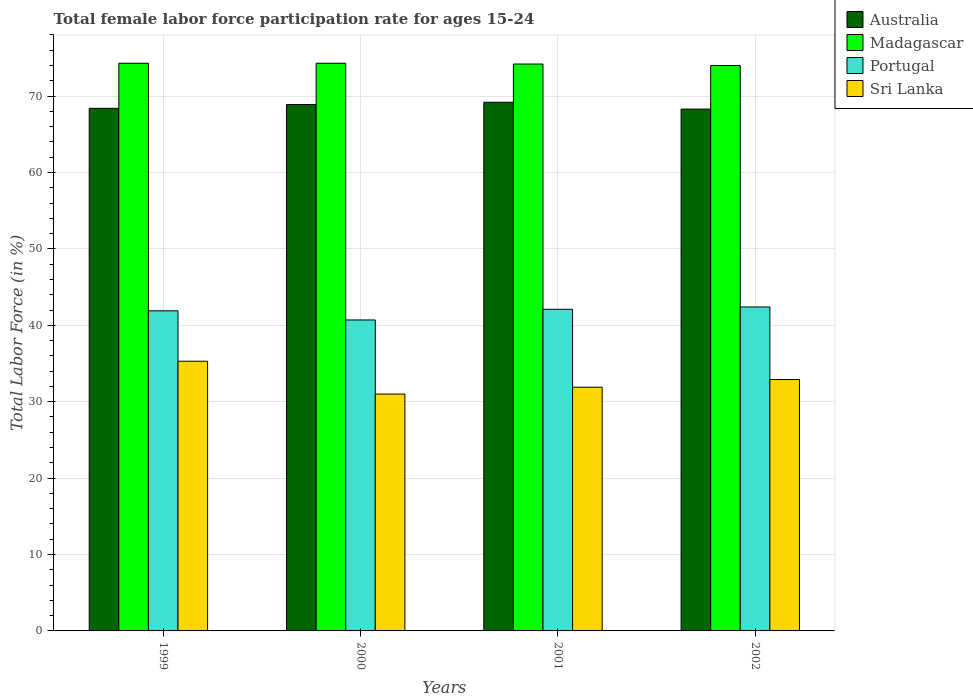Are the number of bars per tick equal to the number of legend labels?
Your response must be concise. Yes. Are the number of bars on each tick of the X-axis equal?
Your answer should be very brief. Yes. How many bars are there on the 4th tick from the right?
Your answer should be compact. 4. What is the label of the 4th group of bars from the left?
Offer a terse response. 2002. In how many cases, is the number of bars for a given year not equal to the number of legend labels?
Offer a very short reply. 0. What is the female labor force participation rate in Sri Lanka in 2001?
Offer a very short reply. 31.9. Across all years, what is the maximum female labor force participation rate in Portugal?
Your response must be concise. 42.4. Across all years, what is the minimum female labor force participation rate in Portugal?
Offer a very short reply. 40.7. In which year was the female labor force participation rate in Madagascar maximum?
Your response must be concise. 1999. What is the total female labor force participation rate in Madagascar in the graph?
Offer a terse response. 296.8. What is the difference between the female labor force participation rate in Australia in 2000 and that in 2001?
Provide a succinct answer. -0.3. What is the difference between the female labor force participation rate in Madagascar in 2000 and the female labor force participation rate in Australia in 2001?
Keep it short and to the point. 5.1. What is the average female labor force participation rate in Portugal per year?
Your response must be concise. 41.78. In the year 2001, what is the difference between the female labor force participation rate in Australia and female labor force participation rate in Sri Lanka?
Provide a short and direct response. 37.3. What is the ratio of the female labor force participation rate in Madagascar in 1999 to that in 2001?
Ensure brevity in your answer.  1. Is the female labor force participation rate in Madagascar in 1999 less than that in 2000?
Ensure brevity in your answer.  No. What is the difference between the highest and the second highest female labor force participation rate in Australia?
Provide a short and direct response. 0.3. What is the difference between the highest and the lowest female labor force participation rate in Australia?
Keep it short and to the point. 0.9. In how many years, is the female labor force participation rate in Portugal greater than the average female labor force participation rate in Portugal taken over all years?
Your response must be concise. 3. What does the 3rd bar from the right in 2001 represents?
Your answer should be compact. Madagascar. Are the values on the major ticks of Y-axis written in scientific E-notation?
Keep it short and to the point. No. Where does the legend appear in the graph?
Make the answer very short. Top right. What is the title of the graph?
Offer a very short reply. Total female labor force participation rate for ages 15-24. Does "Slovenia" appear as one of the legend labels in the graph?
Give a very brief answer. No. What is the Total Labor Force (in %) of Australia in 1999?
Provide a succinct answer. 68.4. What is the Total Labor Force (in %) in Madagascar in 1999?
Make the answer very short. 74.3. What is the Total Labor Force (in %) of Portugal in 1999?
Your answer should be very brief. 41.9. What is the Total Labor Force (in %) in Sri Lanka in 1999?
Give a very brief answer. 35.3. What is the Total Labor Force (in %) of Australia in 2000?
Ensure brevity in your answer.  68.9. What is the Total Labor Force (in %) in Madagascar in 2000?
Provide a succinct answer. 74.3. What is the Total Labor Force (in %) of Portugal in 2000?
Give a very brief answer. 40.7. What is the Total Labor Force (in %) of Sri Lanka in 2000?
Make the answer very short. 31. What is the Total Labor Force (in %) of Australia in 2001?
Make the answer very short. 69.2. What is the Total Labor Force (in %) of Madagascar in 2001?
Provide a succinct answer. 74.2. What is the Total Labor Force (in %) of Portugal in 2001?
Your answer should be very brief. 42.1. What is the Total Labor Force (in %) in Sri Lanka in 2001?
Ensure brevity in your answer.  31.9. What is the Total Labor Force (in %) of Australia in 2002?
Provide a short and direct response. 68.3. What is the Total Labor Force (in %) in Madagascar in 2002?
Your answer should be compact. 74. What is the Total Labor Force (in %) of Portugal in 2002?
Your response must be concise. 42.4. What is the Total Labor Force (in %) in Sri Lanka in 2002?
Offer a very short reply. 32.9. Across all years, what is the maximum Total Labor Force (in %) in Australia?
Offer a terse response. 69.2. Across all years, what is the maximum Total Labor Force (in %) of Madagascar?
Make the answer very short. 74.3. Across all years, what is the maximum Total Labor Force (in %) in Portugal?
Your answer should be compact. 42.4. Across all years, what is the maximum Total Labor Force (in %) in Sri Lanka?
Your response must be concise. 35.3. Across all years, what is the minimum Total Labor Force (in %) of Australia?
Offer a very short reply. 68.3. Across all years, what is the minimum Total Labor Force (in %) of Portugal?
Your answer should be compact. 40.7. Across all years, what is the minimum Total Labor Force (in %) of Sri Lanka?
Keep it short and to the point. 31. What is the total Total Labor Force (in %) in Australia in the graph?
Make the answer very short. 274.8. What is the total Total Labor Force (in %) in Madagascar in the graph?
Provide a succinct answer. 296.8. What is the total Total Labor Force (in %) in Portugal in the graph?
Make the answer very short. 167.1. What is the total Total Labor Force (in %) of Sri Lanka in the graph?
Make the answer very short. 131.1. What is the difference between the Total Labor Force (in %) of Australia in 1999 and that in 2001?
Provide a short and direct response. -0.8. What is the difference between the Total Labor Force (in %) of Portugal in 1999 and that in 2001?
Ensure brevity in your answer.  -0.2. What is the difference between the Total Labor Force (in %) in Australia in 1999 and that in 2002?
Make the answer very short. 0.1. What is the difference between the Total Labor Force (in %) of Madagascar in 1999 and that in 2002?
Offer a very short reply. 0.3. What is the difference between the Total Labor Force (in %) of Sri Lanka in 1999 and that in 2002?
Make the answer very short. 2.4. What is the difference between the Total Labor Force (in %) in Australia in 2000 and that in 2001?
Make the answer very short. -0.3. What is the difference between the Total Labor Force (in %) in Portugal in 2000 and that in 2001?
Offer a very short reply. -1.4. What is the difference between the Total Labor Force (in %) in Australia in 1999 and the Total Labor Force (in %) in Portugal in 2000?
Ensure brevity in your answer.  27.7. What is the difference between the Total Labor Force (in %) of Australia in 1999 and the Total Labor Force (in %) of Sri Lanka in 2000?
Your answer should be compact. 37.4. What is the difference between the Total Labor Force (in %) of Madagascar in 1999 and the Total Labor Force (in %) of Portugal in 2000?
Your answer should be very brief. 33.6. What is the difference between the Total Labor Force (in %) in Madagascar in 1999 and the Total Labor Force (in %) in Sri Lanka in 2000?
Provide a succinct answer. 43.3. What is the difference between the Total Labor Force (in %) in Portugal in 1999 and the Total Labor Force (in %) in Sri Lanka in 2000?
Provide a succinct answer. 10.9. What is the difference between the Total Labor Force (in %) in Australia in 1999 and the Total Labor Force (in %) in Portugal in 2001?
Offer a very short reply. 26.3. What is the difference between the Total Labor Force (in %) in Australia in 1999 and the Total Labor Force (in %) in Sri Lanka in 2001?
Make the answer very short. 36.5. What is the difference between the Total Labor Force (in %) in Madagascar in 1999 and the Total Labor Force (in %) in Portugal in 2001?
Offer a terse response. 32.2. What is the difference between the Total Labor Force (in %) in Madagascar in 1999 and the Total Labor Force (in %) in Sri Lanka in 2001?
Provide a short and direct response. 42.4. What is the difference between the Total Labor Force (in %) in Portugal in 1999 and the Total Labor Force (in %) in Sri Lanka in 2001?
Offer a very short reply. 10. What is the difference between the Total Labor Force (in %) of Australia in 1999 and the Total Labor Force (in %) of Portugal in 2002?
Keep it short and to the point. 26. What is the difference between the Total Labor Force (in %) of Australia in 1999 and the Total Labor Force (in %) of Sri Lanka in 2002?
Your answer should be compact. 35.5. What is the difference between the Total Labor Force (in %) of Madagascar in 1999 and the Total Labor Force (in %) of Portugal in 2002?
Make the answer very short. 31.9. What is the difference between the Total Labor Force (in %) of Madagascar in 1999 and the Total Labor Force (in %) of Sri Lanka in 2002?
Make the answer very short. 41.4. What is the difference between the Total Labor Force (in %) of Portugal in 1999 and the Total Labor Force (in %) of Sri Lanka in 2002?
Make the answer very short. 9. What is the difference between the Total Labor Force (in %) of Australia in 2000 and the Total Labor Force (in %) of Madagascar in 2001?
Give a very brief answer. -5.3. What is the difference between the Total Labor Force (in %) in Australia in 2000 and the Total Labor Force (in %) in Portugal in 2001?
Make the answer very short. 26.8. What is the difference between the Total Labor Force (in %) of Australia in 2000 and the Total Labor Force (in %) of Sri Lanka in 2001?
Offer a terse response. 37. What is the difference between the Total Labor Force (in %) of Madagascar in 2000 and the Total Labor Force (in %) of Portugal in 2001?
Make the answer very short. 32.2. What is the difference between the Total Labor Force (in %) in Madagascar in 2000 and the Total Labor Force (in %) in Sri Lanka in 2001?
Your answer should be compact. 42.4. What is the difference between the Total Labor Force (in %) of Madagascar in 2000 and the Total Labor Force (in %) of Portugal in 2002?
Your answer should be very brief. 31.9. What is the difference between the Total Labor Force (in %) of Madagascar in 2000 and the Total Labor Force (in %) of Sri Lanka in 2002?
Keep it short and to the point. 41.4. What is the difference between the Total Labor Force (in %) of Portugal in 2000 and the Total Labor Force (in %) of Sri Lanka in 2002?
Your answer should be very brief. 7.8. What is the difference between the Total Labor Force (in %) in Australia in 2001 and the Total Labor Force (in %) in Madagascar in 2002?
Your response must be concise. -4.8. What is the difference between the Total Labor Force (in %) in Australia in 2001 and the Total Labor Force (in %) in Portugal in 2002?
Ensure brevity in your answer.  26.8. What is the difference between the Total Labor Force (in %) in Australia in 2001 and the Total Labor Force (in %) in Sri Lanka in 2002?
Keep it short and to the point. 36.3. What is the difference between the Total Labor Force (in %) of Madagascar in 2001 and the Total Labor Force (in %) of Portugal in 2002?
Provide a succinct answer. 31.8. What is the difference between the Total Labor Force (in %) of Madagascar in 2001 and the Total Labor Force (in %) of Sri Lanka in 2002?
Offer a very short reply. 41.3. What is the average Total Labor Force (in %) in Australia per year?
Your response must be concise. 68.7. What is the average Total Labor Force (in %) in Madagascar per year?
Ensure brevity in your answer.  74.2. What is the average Total Labor Force (in %) in Portugal per year?
Ensure brevity in your answer.  41.77. What is the average Total Labor Force (in %) of Sri Lanka per year?
Provide a succinct answer. 32.77. In the year 1999, what is the difference between the Total Labor Force (in %) in Australia and Total Labor Force (in %) in Madagascar?
Your answer should be compact. -5.9. In the year 1999, what is the difference between the Total Labor Force (in %) of Australia and Total Labor Force (in %) of Portugal?
Keep it short and to the point. 26.5. In the year 1999, what is the difference between the Total Labor Force (in %) in Australia and Total Labor Force (in %) in Sri Lanka?
Provide a short and direct response. 33.1. In the year 1999, what is the difference between the Total Labor Force (in %) in Madagascar and Total Labor Force (in %) in Portugal?
Make the answer very short. 32.4. In the year 1999, what is the difference between the Total Labor Force (in %) in Madagascar and Total Labor Force (in %) in Sri Lanka?
Give a very brief answer. 39. In the year 1999, what is the difference between the Total Labor Force (in %) in Portugal and Total Labor Force (in %) in Sri Lanka?
Your answer should be compact. 6.6. In the year 2000, what is the difference between the Total Labor Force (in %) of Australia and Total Labor Force (in %) of Portugal?
Your answer should be very brief. 28.2. In the year 2000, what is the difference between the Total Labor Force (in %) in Australia and Total Labor Force (in %) in Sri Lanka?
Your answer should be very brief. 37.9. In the year 2000, what is the difference between the Total Labor Force (in %) of Madagascar and Total Labor Force (in %) of Portugal?
Provide a succinct answer. 33.6. In the year 2000, what is the difference between the Total Labor Force (in %) of Madagascar and Total Labor Force (in %) of Sri Lanka?
Your answer should be very brief. 43.3. In the year 2000, what is the difference between the Total Labor Force (in %) in Portugal and Total Labor Force (in %) in Sri Lanka?
Your answer should be very brief. 9.7. In the year 2001, what is the difference between the Total Labor Force (in %) of Australia and Total Labor Force (in %) of Madagascar?
Keep it short and to the point. -5. In the year 2001, what is the difference between the Total Labor Force (in %) of Australia and Total Labor Force (in %) of Portugal?
Your answer should be compact. 27.1. In the year 2001, what is the difference between the Total Labor Force (in %) in Australia and Total Labor Force (in %) in Sri Lanka?
Ensure brevity in your answer.  37.3. In the year 2001, what is the difference between the Total Labor Force (in %) of Madagascar and Total Labor Force (in %) of Portugal?
Give a very brief answer. 32.1. In the year 2001, what is the difference between the Total Labor Force (in %) of Madagascar and Total Labor Force (in %) of Sri Lanka?
Your response must be concise. 42.3. In the year 2001, what is the difference between the Total Labor Force (in %) of Portugal and Total Labor Force (in %) of Sri Lanka?
Give a very brief answer. 10.2. In the year 2002, what is the difference between the Total Labor Force (in %) in Australia and Total Labor Force (in %) in Portugal?
Offer a terse response. 25.9. In the year 2002, what is the difference between the Total Labor Force (in %) of Australia and Total Labor Force (in %) of Sri Lanka?
Your response must be concise. 35.4. In the year 2002, what is the difference between the Total Labor Force (in %) in Madagascar and Total Labor Force (in %) in Portugal?
Give a very brief answer. 31.6. In the year 2002, what is the difference between the Total Labor Force (in %) in Madagascar and Total Labor Force (in %) in Sri Lanka?
Ensure brevity in your answer.  41.1. In the year 2002, what is the difference between the Total Labor Force (in %) of Portugal and Total Labor Force (in %) of Sri Lanka?
Keep it short and to the point. 9.5. What is the ratio of the Total Labor Force (in %) in Australia in 1999 to that in 2000?
Offer a terse response. 0.99. What is the ratio of the Total Labor Force (in %) of Madagascar in 1999 to that in 2000?
Ensure brevity in your answer.  1. What is the ratio of the Total Labor Force (in %) in Portugal in 1999 to that in 2000?
Ensure brevity in your answer.  1.03. What is the ratio of the Total Labor Force (in %) in Sri Lanka in 1999 to that in 2000?
Give a very brief answer. 1.14. What is the ratio of the Total Labor Force (in %) in Australia in 1999 to that in 2001?
Make the answer very short. 0.99. What is the ratio of the Total Labor Force (in %) of Madagascar in 1999 to that in 2001?
Provide a short and direct response. 1. What is the ratio of the Total Labor Force (in %) of Sri Lanka in 1999 to that in 2001?
Provide a short and direct response. 1.11. What is the ratio of the Total Labor Force (in %) in Sri Lanka in 1999 to that in 2002?
Ensure brevity in your answer.  1.07. What is the ratio of the Total Labor Force (in %) of Madagascar in 2000 to that in 2001?
Your response must be concise. 1. What is the ratio of the Total Labor Force (in %) in Portugal in 2000 to that in 2001?
Provide a short and direct response. 0.97. What is the ratio of the Total Labor Force (in %) in Sri Lanka in 2000 to that in 2001?
Your answer should be compact. 0.97. What is the ratio of the Total Labor Force (in %) in Australia in 2000 to that in 2002?
Give a very brief answer. 1.01. What is the ratio of the Total Labor Force (in %) of Portugal in 2000 to that in 2002?
Offer a very short reply. 0.96. What is the ratio of the Total Labor Force (in %) in Sri Lanka in 2000 to that in 2002?
Offer a terse response. 0.94. What is the ratio of the Total Labor Force (in %) in Australia in 2001 to that in 2002?
Ensure brevity in your answer.  1.01. What is the ratio of the Total Labor Force (in %) in Madagascar in 2001 to that in 2002?
Make the answer very short. 1. What is the ratio of the Total Labor Force (in %) in Portugal in 2001 to that in 2002?
Your response must be concise. 0.99. What is the ratio of the Total Labor Force (in %) of Sri Lanka in 2001 to that in 2002?
Offer a very short reply. 0.97. What is the difference between the highest and the second highest Total Labor Force (in %) of Australia?
Offer a very short reply. 0.3. What is the difference between the highest and the second highest Total Labor Force (in %) in Madagascar?
Provide a succinct answer. 0. What is the difference between the highest and the second highest Total Labor Force (in %) of Portugal?
Your answer should be very brief. 0.3. What is the difference between the highest and the second highest Total Labor Force (in %) in Sri Lanka?
Ensure brevity in your answer.  2.4. What is the difference between the highest and the lowest Total Labor Force (in %) of Australia?
Make the answer very short. 0.9. What is the difference between the highest and the lowest Total Labor Force (in %) of Madagascar?
Provide a succinct answer. 0.3. What is the difference between the highest and the lowest Total Labor Force (in %) in Portugal?
Keep it short and to the point. 1.7. What is the difference between the highest and the lowest Total Labor Force (in %) of Sri Lanka?
Give a very brief answer. 4.3. 